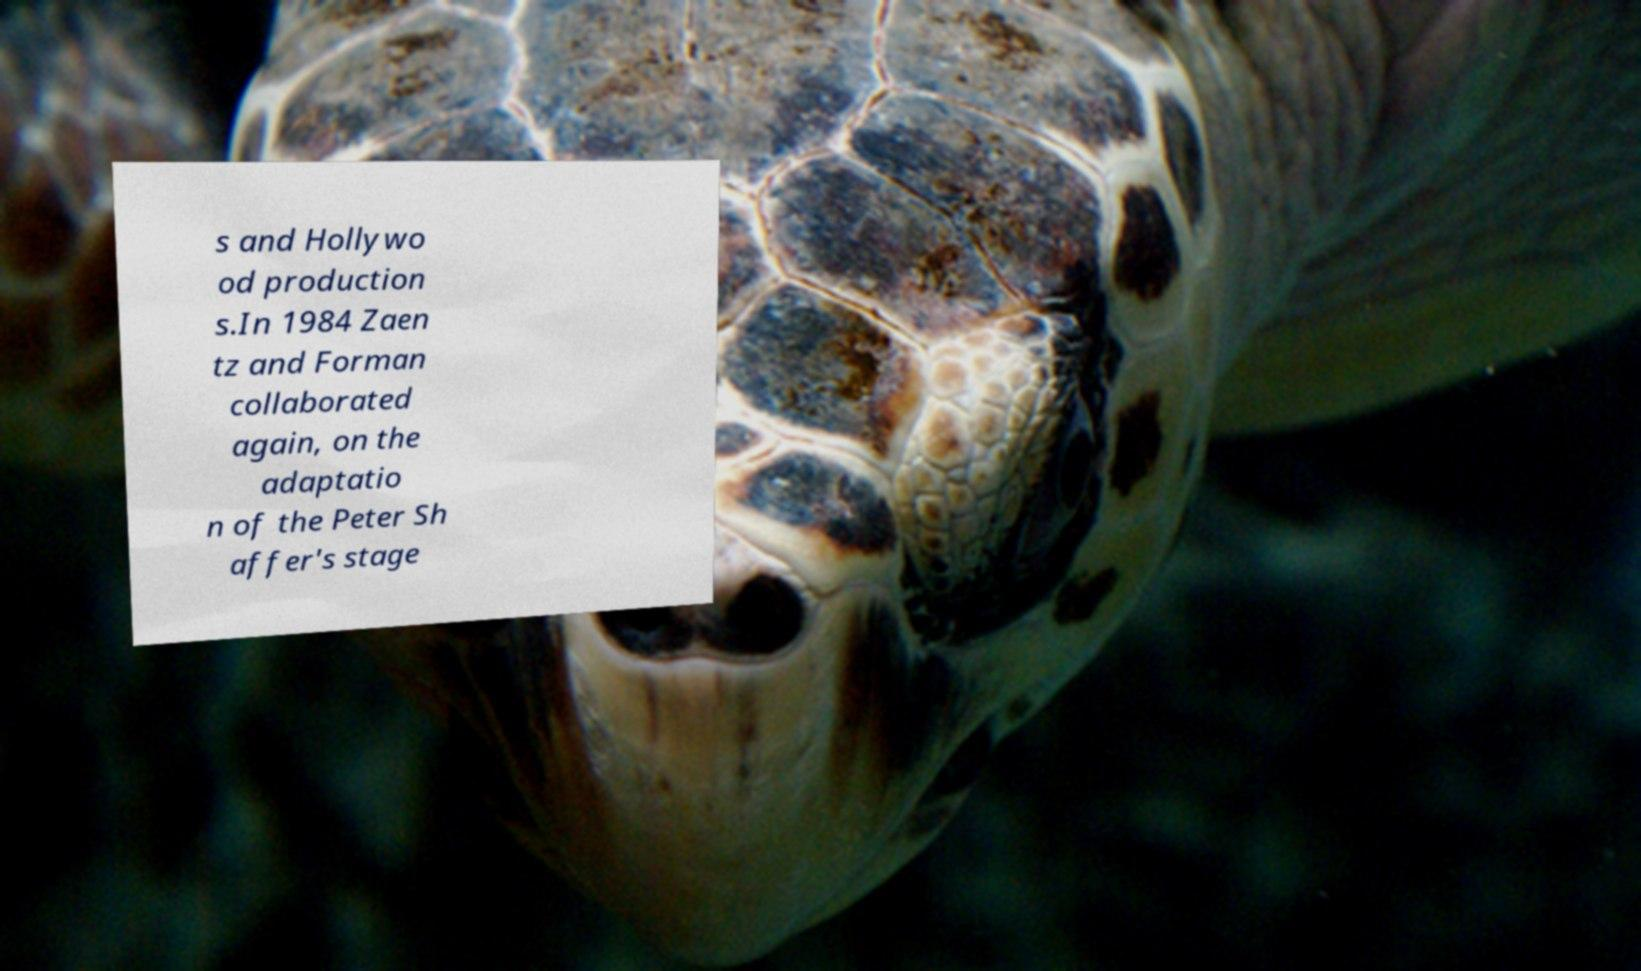Could you assist in decoding the text presented in this image and type it out clearly? s and Hollywo od production s.In 1984 Zaen tz and Forman collaborated again, on the adaptatio n of the Peter Sh affer's stage 